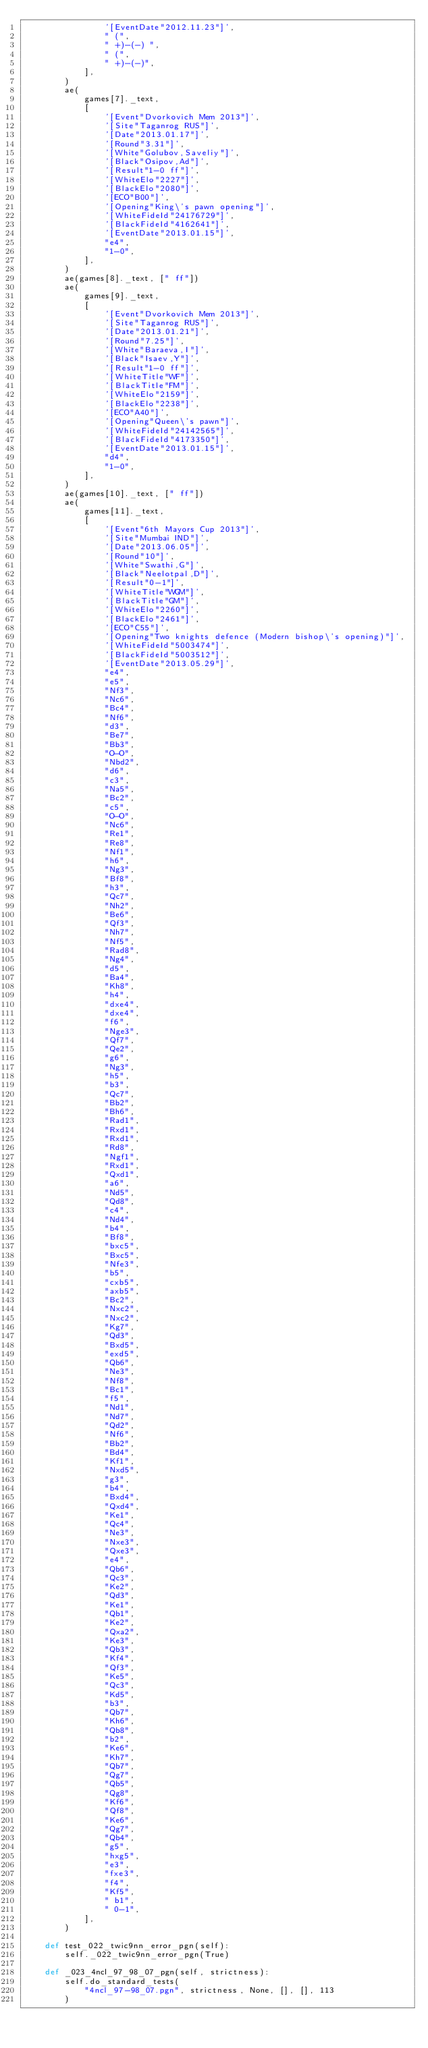Convert code to text. <code><loc_0><loc_0><loc_500><loc_500><_Python_>                '[EventDate"2012.11.23"]',
                " (",
                " +)-(-) ",
                " (",
                " +)-(-)",
            ],
        )
        ae(
            games[7]._text,
            [
                '[Event"Dvorkovich Mem 2013"]',
                '[Site"Taganrog RUS"]',
                '[Date"2013.01.17"]',
                '[Round"3.31"]',
                '[White"Golubov,Saveliy"]',
                '[Black"Osipov,Ad"]',
                '[Result"1-0 ff"]',
                '[WhiteElo"2227"]',
                '[BlackElo"2080"]',
                '[ECO"B00"]',
                '[Opening"King\'s pawn opening"]',
                '[WhiteFideId"24176729"]',
                '[BlackFideId"4162641"]',
                '[EventDate"2013.01.15"]',
                "e4",
                "1-0",
            ],
        )
        ae(games[8]._text, [" ff"])
        ae(
            games[9]._text,
            [
                '[Event"Dvorkovich Mem 2013"]',
                '[Site"Taganrog RUS"]',
                '[Date"2013.01.21"]',
                '[Round"7.25"]',
                '[White"Baraeva,I"]',
                '[Black"Isaev,Y"]',
                '[Result"1-0 ff"]',
                '[WhiteTitle"WF"]',
                '[BlackTitle"FM"]',
                '[WhiteElo"2159"]',
                '[BlackElo"2238"]',
                '[ECO"A40"]',
                '[Opening"Queen\'s pawn"]',
                '[WhiteFideId"24142565"]',
                '[BlackFideId"4173350"]',
                '[EventDate"2013.01.15"]',
                "d4",
                "1-0",
            ],
        )
        ae(games[10]._text, [" ff"])
        ae(
            games[11]._text,
            [
                '[Event"6th Mayors Cup 2013"]',
                '[Site"Mumbai IND"]',
                '[Date"2013.06.05"]',
                '[Round"10"]',
                '[White"Swathi,G"]',
                '[Black"Neelotpal,D"]',
                '[Result"0-1"]',
                '[WhiteTitle"WGM"]',
                '[BlackTitle"GM"]',
                '[WhiteElo"2260"]',
                '[BlackElo"2461"]',
                '[ECO"C55"]',
                '[Opening"Two knights defence (Modern bishop\'s opening)"]',
                '[WhiteFideId"5003474"]',
                '[BlackFideId"5003512"]',
                '[EventDate"2013.05.29"]',
                "e4",
                "e5",
                "Nf3",
                "Nc6",
                "Bc4",
                "Nf6",
                "d3",
                "Be7",
                "Bb3",
                "O-O",
                "Nbd2",
                "d6",
                "c3",
                "Na5",
                "Bc2",
                "c5",
                "O-O",
                "Nc6",
                "Re1",
                "Re8",
                "Nf1",
                "h6",
                "Ng3",
                "Bf8",
                "h3",
                "Qc7",
                "Nh2",
                "Be6",
                "Qf3",
                "Nh7",
                "Nf5",
                "Rad8",
                "Ng4",
                "d5",
                "Ba4",
                "Kh8",
                "h4",
                "dxe4",
                "dxe4",
                "f6",
                "Nge3",
                "Qf7",
                "Qe2",
                "g6",
                "Ng3",
                "h5",
                "b3",
                "Qc7",
                "Bb2",
                "Bh6",
                "Rad1",
                "Rxd1",
                "Rxd1",
                "Rd8",
                "Ngf1",
                "Rxd1",
                "Qxd1",
                "a6",
                "Nd5",
                "Qd8",
                "c4",
                "Nd4",
                "b4",
                "Bf8",
                "bxc5",
                "Bxc5",
                "Nfe3",
                "b5",
                "cxb5",
                "axb5",
                "Bc2",
                "Nxc2",
                "Nxc2",
                "Kg7",
                "Qd3",
                "Bxd5",
                "exd5",
                "Qb6",
                "Ne3",
                "Nf8",
                "Bc1",
                "f5",
                "Nd1",
                "Nd7",
                "Qd2",
                "Nf6",
                "Bb2",
                "Bd4",
                "Kf1",
                "Nxd5",
                "g3",
                "b4",
                "Bxd4",
                "Qxd4",
                "Ke1",
                "Qc4",
                "Ne3",
                "Nxe3",
                "Qxe3",
                "e4",
                "Qb6",
                "Qc3",
                "Ke2",
                "Qd3",
                "Ke1",
                "Qb1",
                "Ke2",
                "Qxa2",
                "Ke3",
                "Qb3",
                "Kf4",
                "Qf3",
                "Ke5",
                "Qc3",
                "Kd5",
                "b3",
                "Qb7",
                "Kh6",
                "Qb8",
                "b2",
                "Ke6",
                "Kh7",
                "Qb7",
                "Qg7",
                "Qb5",
                "Qg8",
                "Kf6",
                "Qf8",
                "Ke6",
                "Qg7",
                "Qb4",
                "g5",
                "hxg5",
                "e3",
                "fxe3",
                "f4",
                "Kf5",
                " b1",
                " 0-1",
            ],
        )

    def test_022_twic9nn_error_pgn(self):
        self._022_twic9nn_error_pgn(True)

    def _023_4ncl_97_98_07_pgn(self, strictness):
        self.do_standard_tests(
            "4ncl_97-98_07.pgn", strictness, None, [], [], 113
        )
</code> 